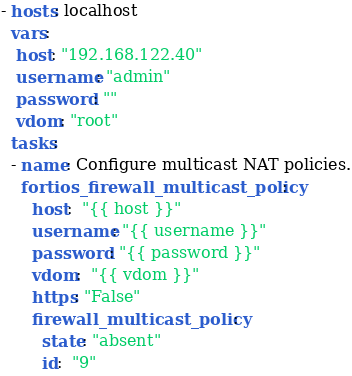<code> <loc_0><loc_0><loc_500><loc_500><_YAML_>- hosts: localhost
  vars:
   host: "192.168.122.40"
   username: "admin"
   password: ""
   vdom: "root"
  tasks:
  - name: Configure multicast NAT policies.
    fortios_firewall_multicast_policy:
      host:  "{{ host }}"
      username: "{{ username }}"
      password: "{{ password }}"
      vdom:  "{{ vdom }}"
      https: "False"
      firewall_multicast_policy:
        state: "absent"
        id:  "9"
</code> 